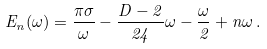Convert formula to latex. <formula><loc_0><loc_0><loc_500><loc_500>E _ { n } ( \omega ) = \frac { \pi \sigma } { \omega } - \frac { D - 2 } { 2 4 } \omega - \frac { \omega } { 2 } + n \omega \, .</formula> 